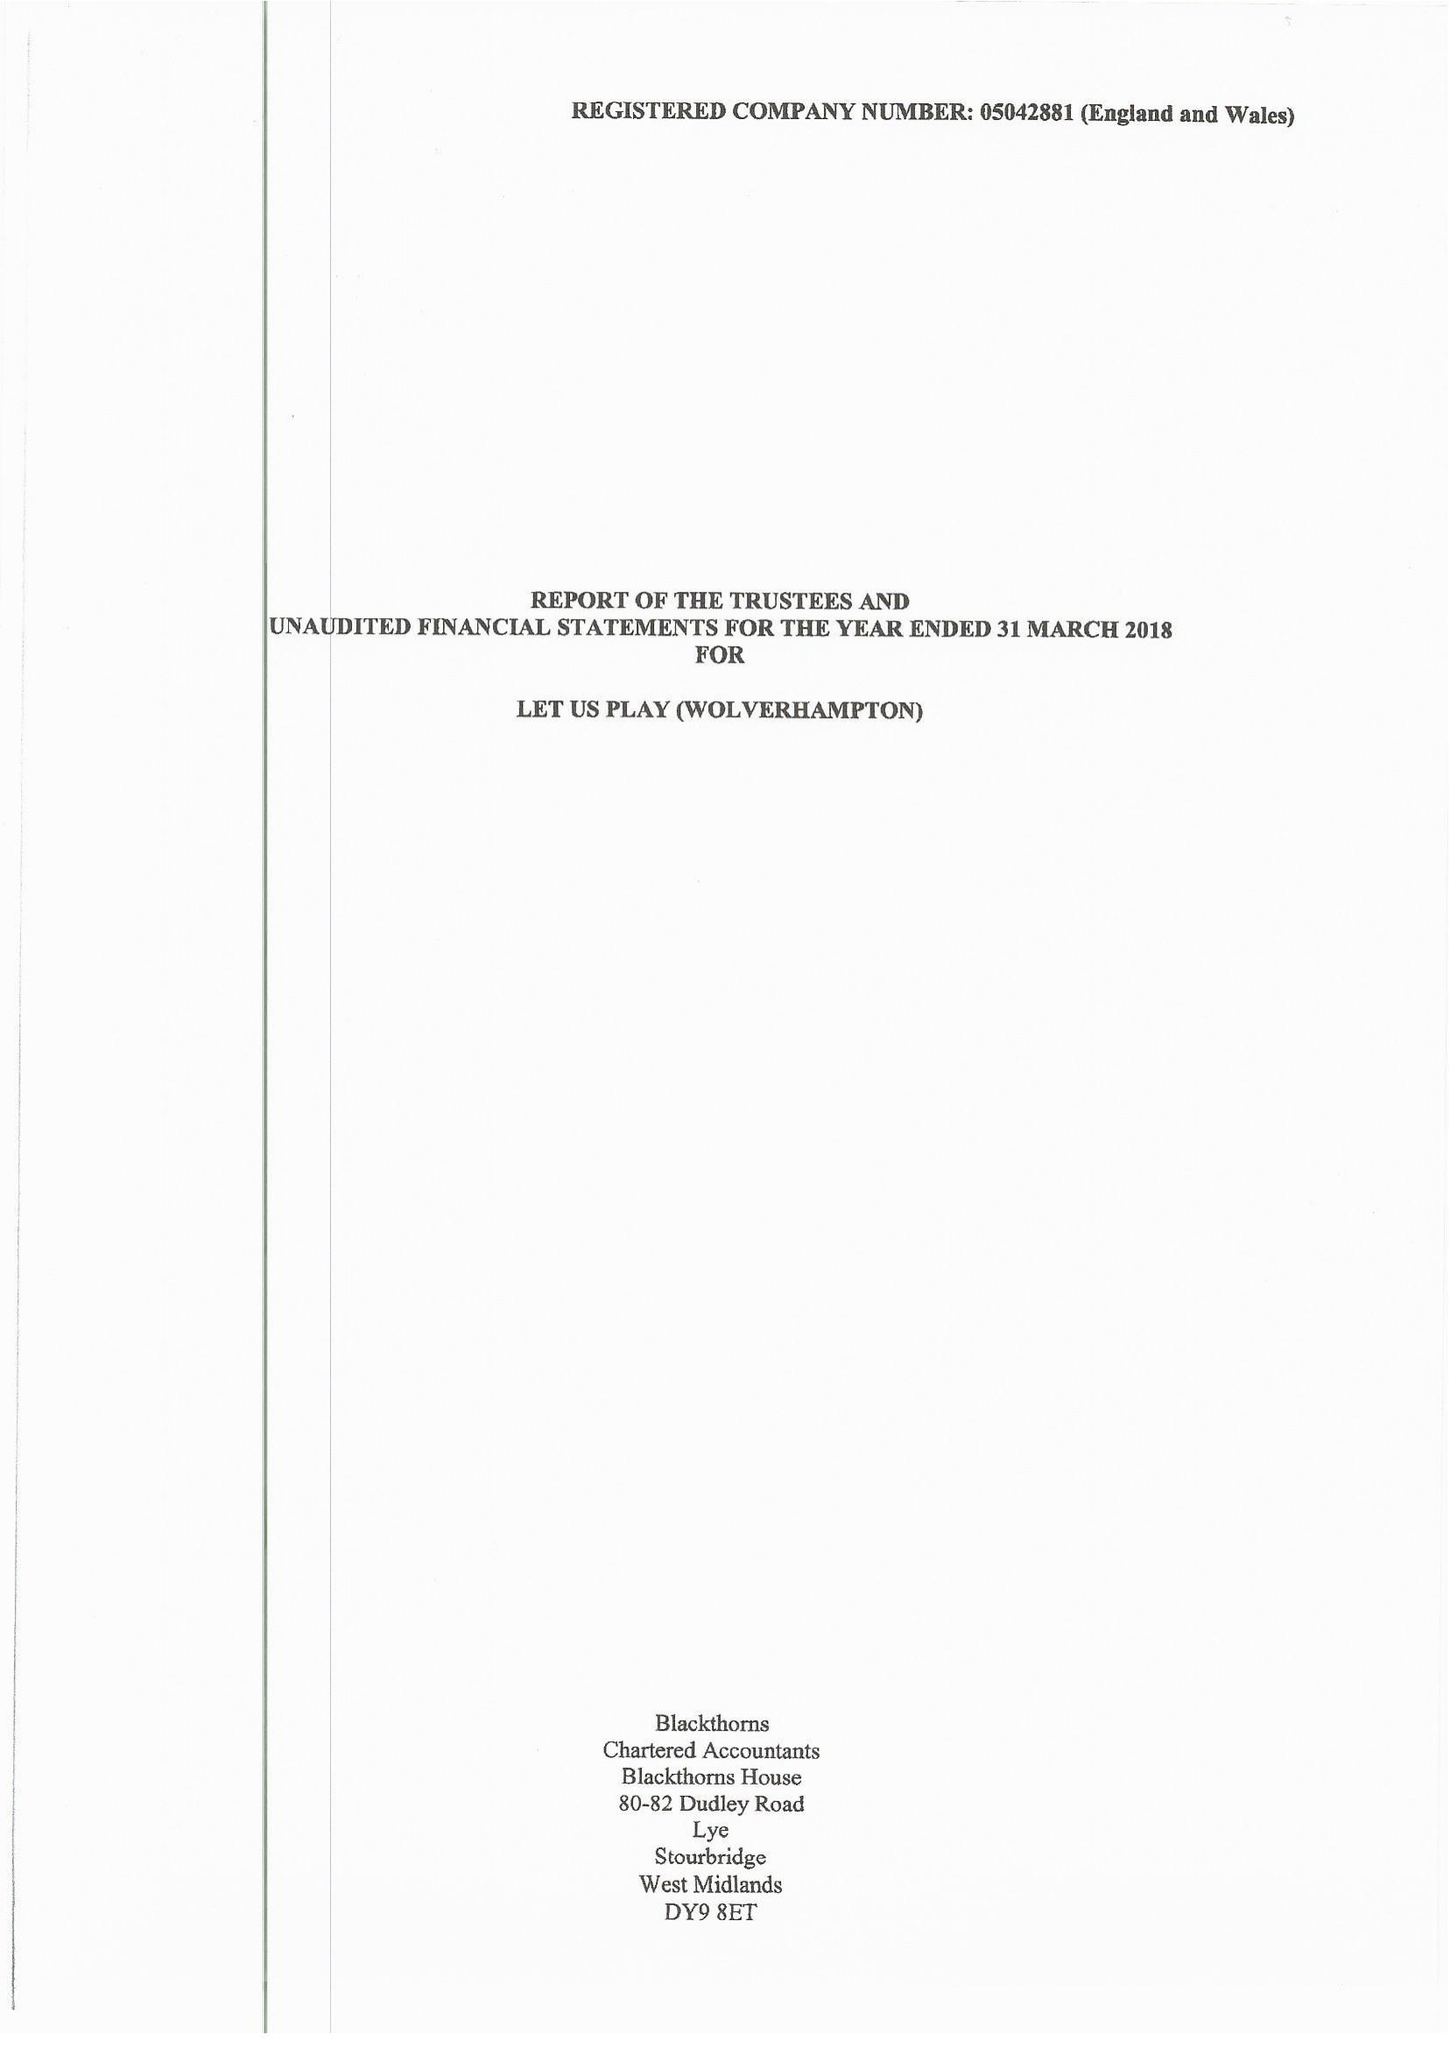What is the value for the income_annually_in_british_pounds?
Answer the question using a single word or phrase. 128535.00 